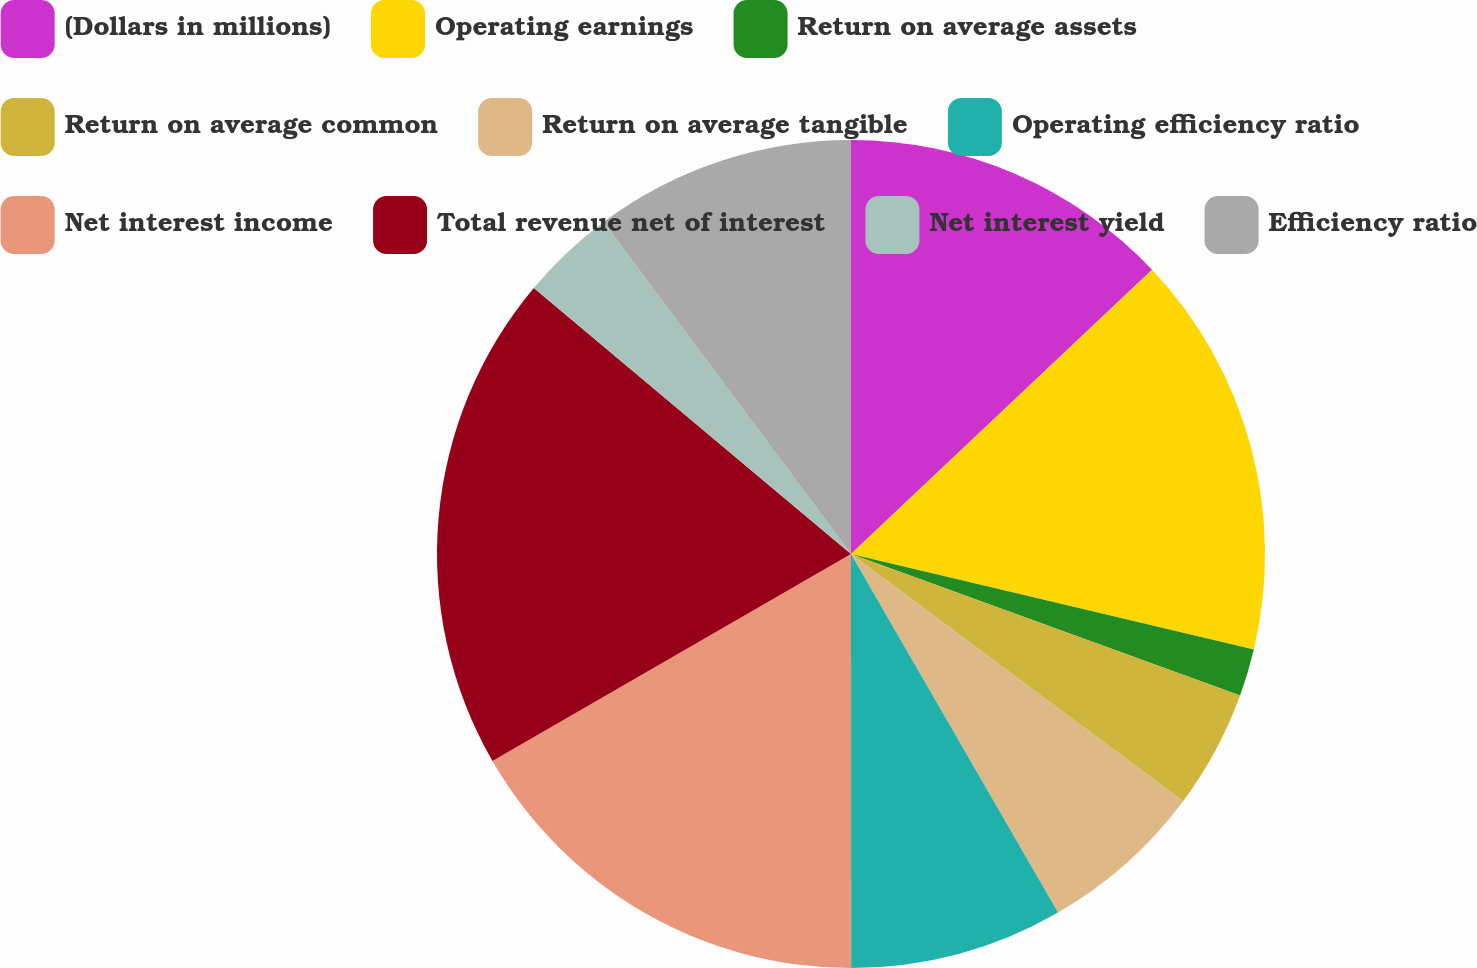Convert chart to OTSL. <chart><loc_0><loc_0><loc_500><loc_500><pie_chart><fcel>(Dollars in millions)<fcel>Operating earnings<fcel>Return on average assets<fcel>Return on average common<fcel>Return on average tangible<fcel>Operating efficiency ratio<fcel>Net interest income<fcel>Total revenue net of interest<fcel>Net interest yield<fcel>Efficiency ratio<nl><fcel>12.96%<fcel>15.74%<fcel>1.85%<fcel>4.63%<fcel>6.48%<fcel>8.33%<fcel>16.67%<fcel>19.44%<fcel>3.7%<fcel>10.19%<nl></chart> 